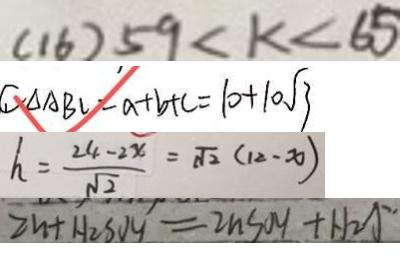Convert formula to latex. <formula><loc_0><loc_0><loc_500><loc_500>( 1 6 ) 5 9 < k < 6 5 
 C _ { \Delta A B C } = a + b + c = 1 0 + 1 0 \sqrt { 3 } 
 h = \frac { 2 4 - 2 x } { \sqrt { 2 } } = \sqrt { 2 } ( 1 2 - x ) 
 2 n + H _ { 2 } S O _ { 4 } = 2 n S O _ { 4 } + H _ { 2 } \uparrow</formula> 